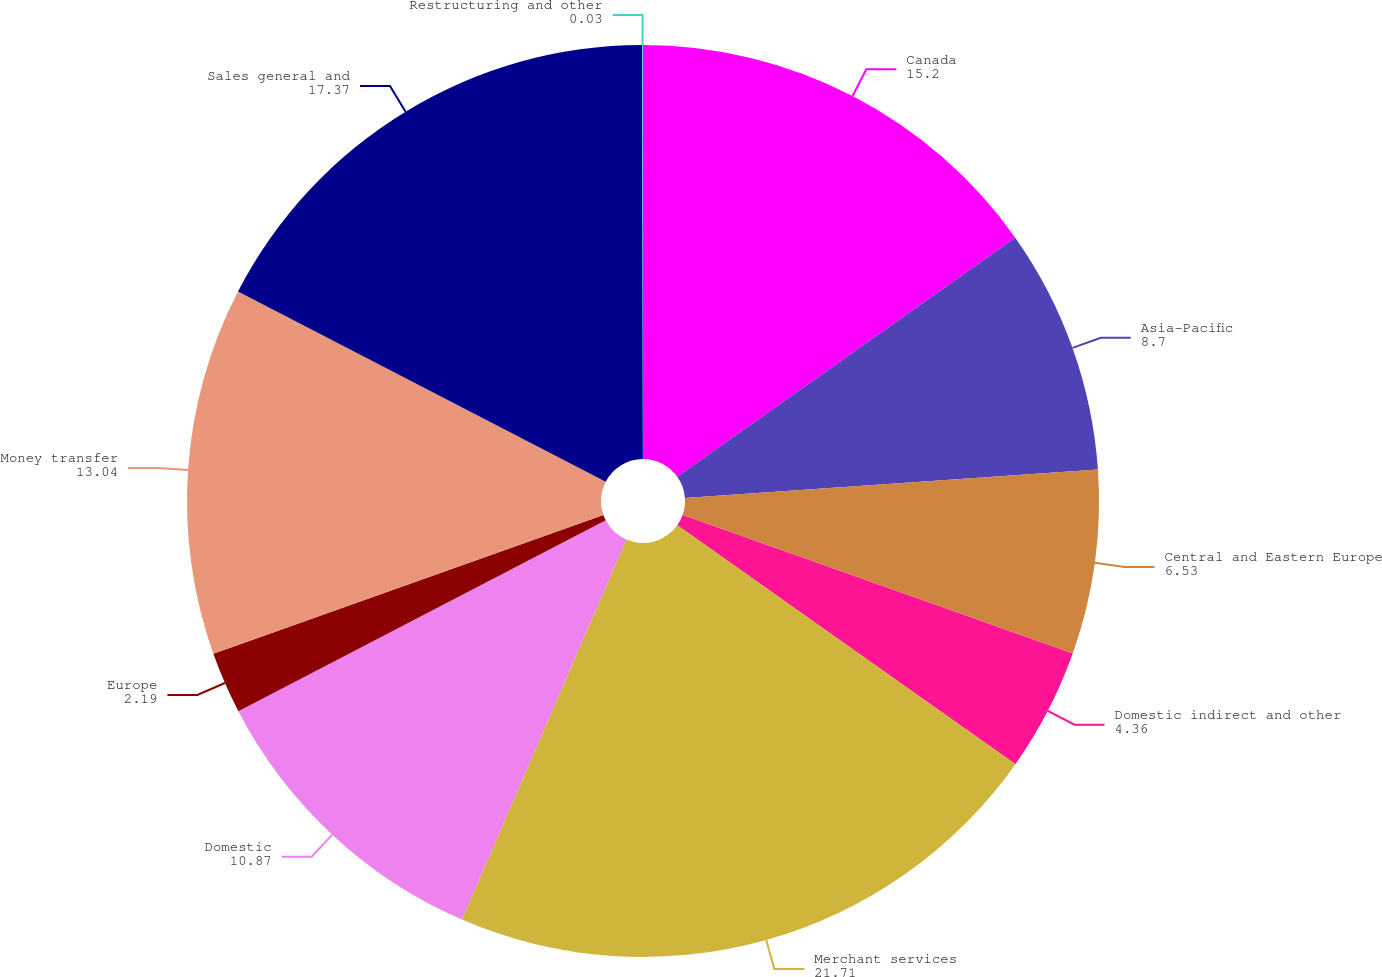Convert chart. <chart><loc_0><loc_0><loc_500><loc_500><pie_chart><fcel>Canada<fcel>Asia-Pacific<fcel>Central and Eastern Europe<fcel>Domestic indirect and other<fcel>Merchant services<fcel>Domestic<fcel>Europe<fcel>Money transfer<fcel>Sales general and<fcel>Restructuring and other<nl><fcel>15.2%<fcel>8.7%<fcel>6.53%<fcel>4.36%<fcel>21.71%<fcel>10.87%<fcel>2.19%<fcel>13.04%<fcel>17.37%<fcel>0.03%<nl></chart> 